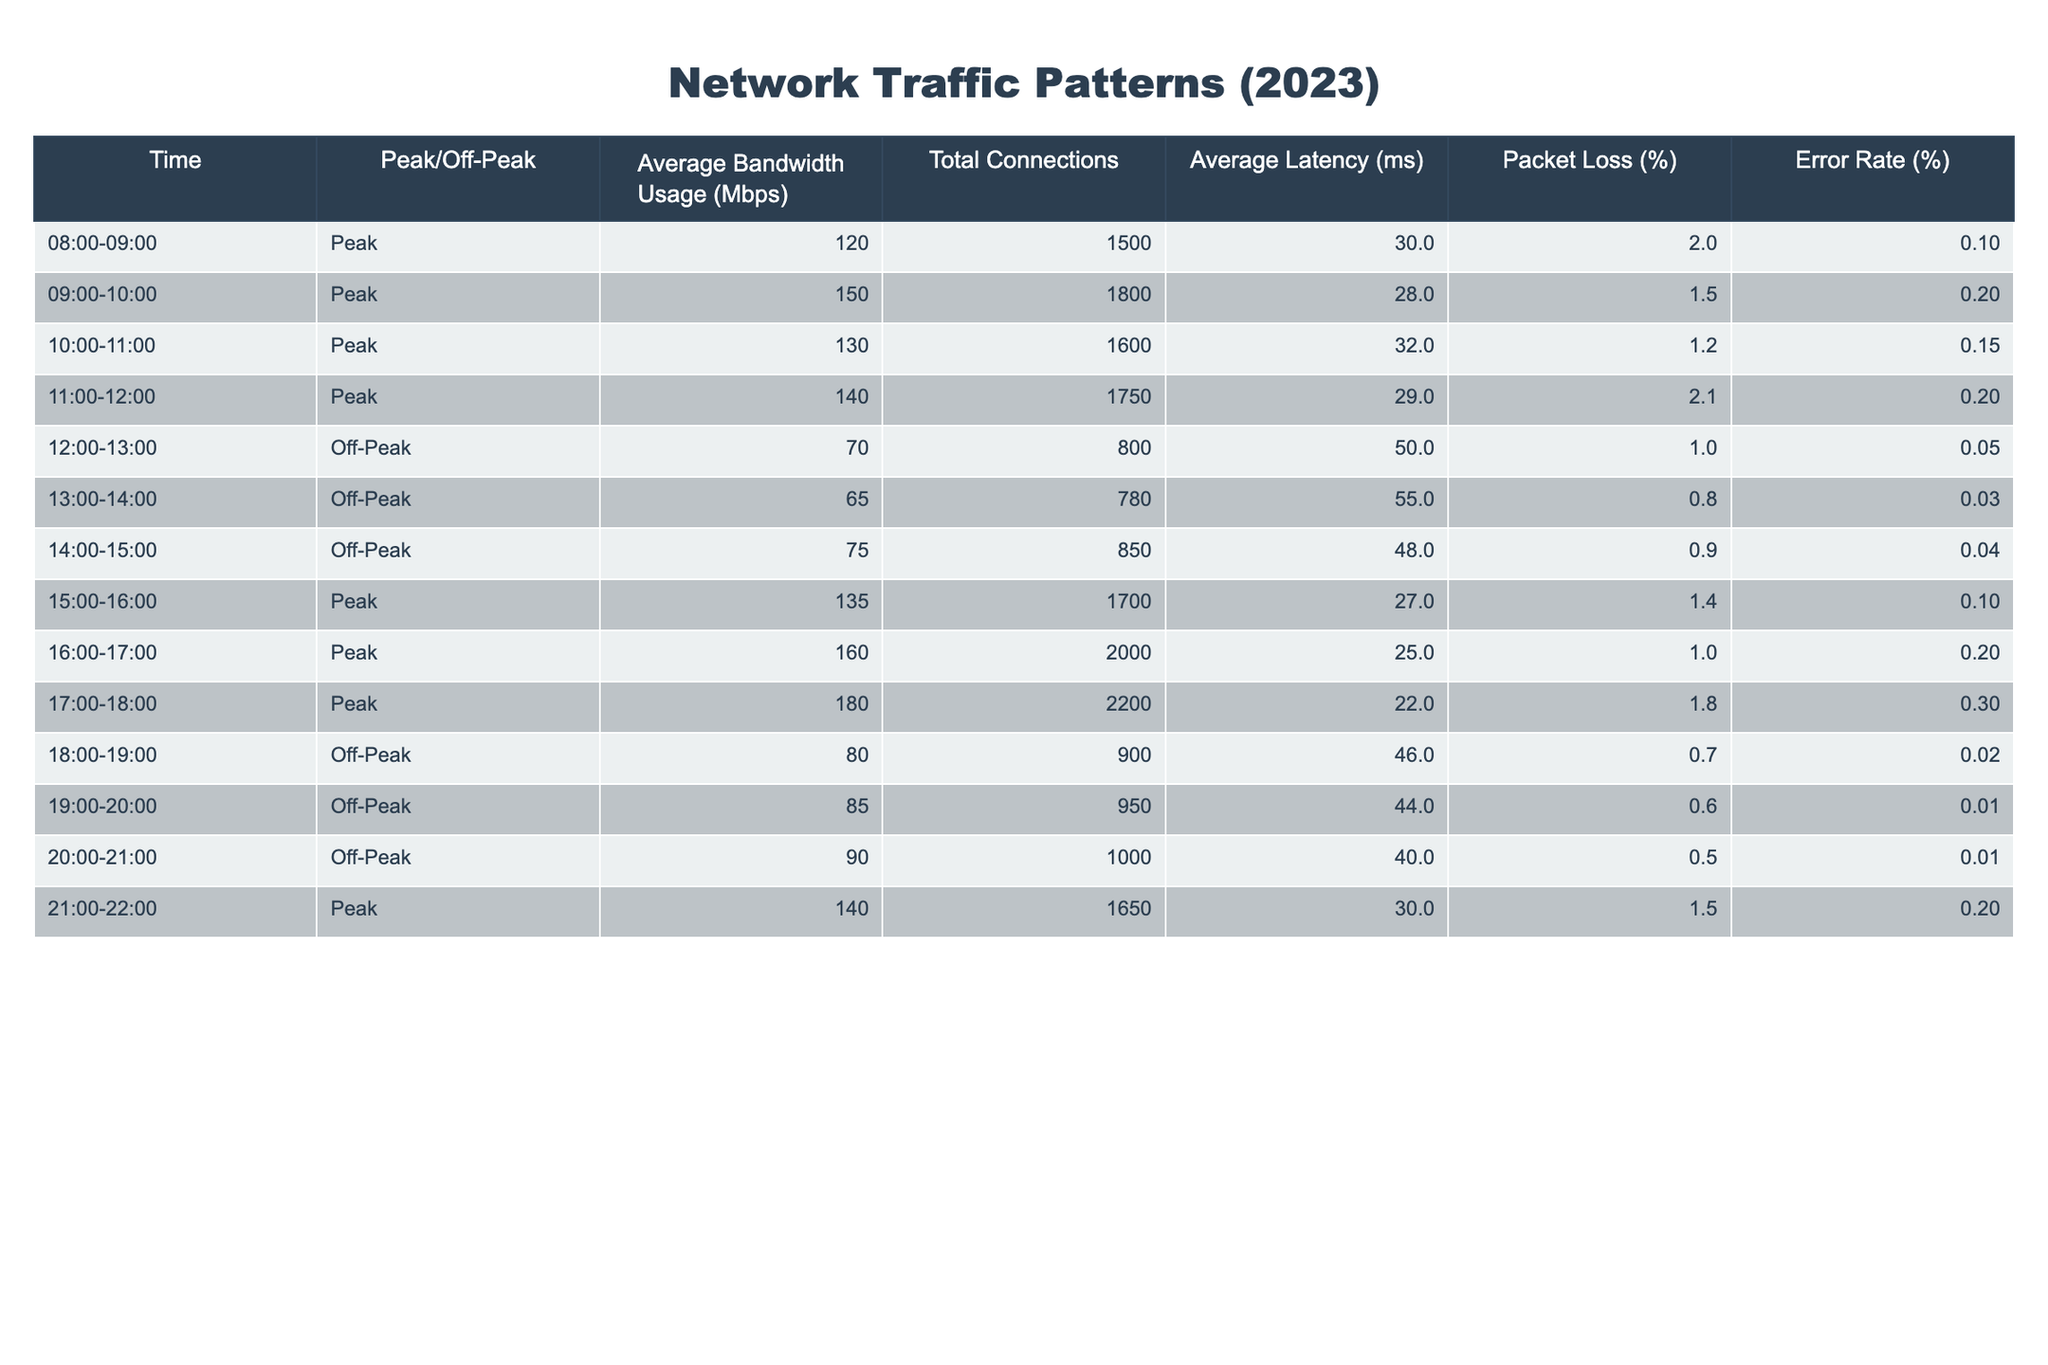What is the average bandwidth usage during peak hours? To find the average bandwidth usage during peak hours, we need to sum the bandwidth values for peak hours (120, 150, 130, 140, 135, 160, 180, 140) which totals 1,095. We then divide this sum by the number of peak hour data points (8), yielding an average of 1,095 / 8 = 136.875 Mbps.
Answer: 136.875 Mbps What is the total number of connections during off-peak hours? The total number of connections during off-peak hours can be found by summing the total connections for off-peak periods (800, 780, 850, 900, 950, 1000), which results in 800 + 780 + 850 + 900 + 950 + 1000 = 4,280 connections.
Answer: 4280 connections Is the error rate during peak hours ever above 0.2%? We check the error rates during peak hours (0.1, 0.2, 0.15, 0.2, 0.1, 0.2, 0.3, 0.2). The maximum value is 0.3%, which is indeed above 0.2%, making the statement true.
Answer: Yes What is the average latency during off-peak hours? First, we identify the average latency for off-peak periods (50, 55, 48, 46, 44, 40). Summing these values gives us 50 + 55 + 48 + 46 + 44 + 40 = 283 ms. Dividing this by 6 (the number of off-peak periods) results in an average latency of 283 / 6 ≈ 47.17 ms.
Answer: 47.17 ms Which hour had the highest total connections? We compare the total connections for all hours: Peak hours - 1500, 1800, 1600, 1750, 1700, 2000, 2200, 1650; Off-peak hours - 800, 780, 850, 900, 950, 1000. The highest total is 2200 at 17:00-18:00.
Answer: 17:00-18:00 What is the difference in average bandwidth usage between peak and off-peak hours? We first found the average bandwidth usage during peak hours (136.875 Mbps). For off-peak hours, we sum the values (70, 65, 75, 80, 85, 90 = 465) and divide by 6, yielding an average of 465 / 6 = 77.5 Mbps. The difference is 136.875 - 77.5 = 59.375 Mbps.
Answer: 59.375 Mbps Is the packet loss percentage generally higher during peak hours compared to off-peak hours? The average packet loss percentage for peak hours is calculated by (2 + 1.5 + 1.2 + 2.1 + 1.4 + 1 + 1.8 + 1.5) / 8 = 1.675%. For off-peak hours, it is (1 + 0.8 + 0.9 + 0.7 + 0.6 + 0.5) / 6 = 0.6667%. Since 1.675% is greater than 0.6667%, the statement is true.
Answer: Yes 